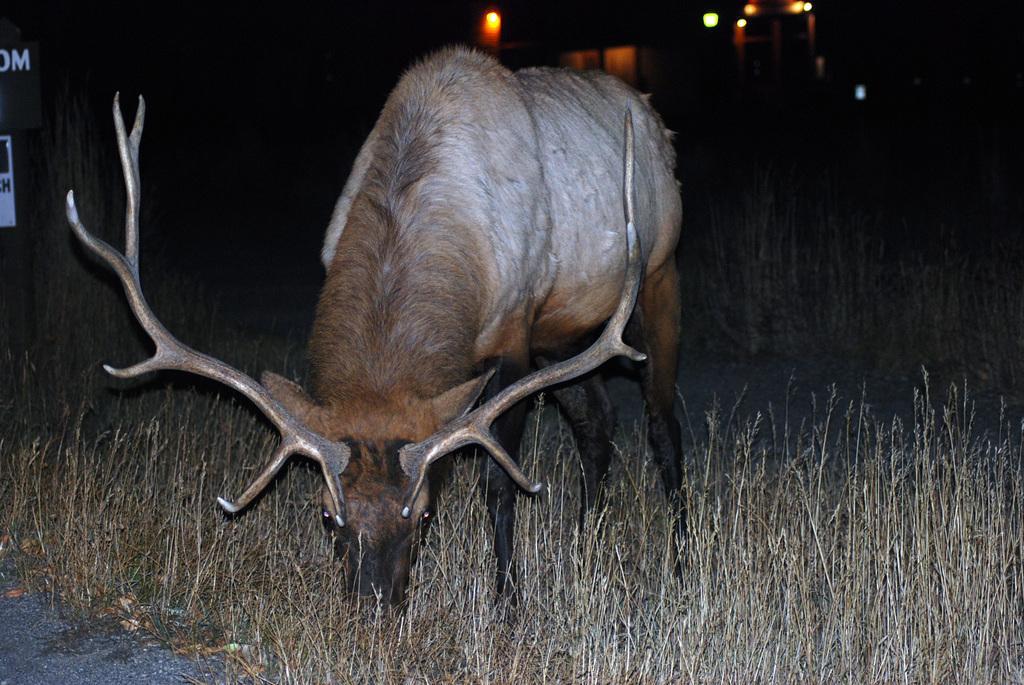In one or two sentences, can you explain what this image depicts? In this image, we can see an animal. There is a grass on the ground. There are lights at the top of the image. 